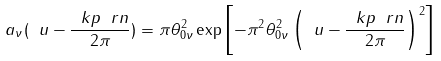Convert formula to latex. <formula><loc_0><loc_0><loc_500><loc_500>a _ { \nu } ( \ u - \frac { \ k p \ r n } { 2 \pi } ) = \pi \theta _ { 0 \nu } ^ { 2 } \exp { \left [ - \pi ^ { 2 } \theta _ { 0 \nu } ^ { 2 } \left ( \ u - \frac { \ k p \ r n } { 2 \pi } \right ) ^ { 2 } \right ] }</formula> 